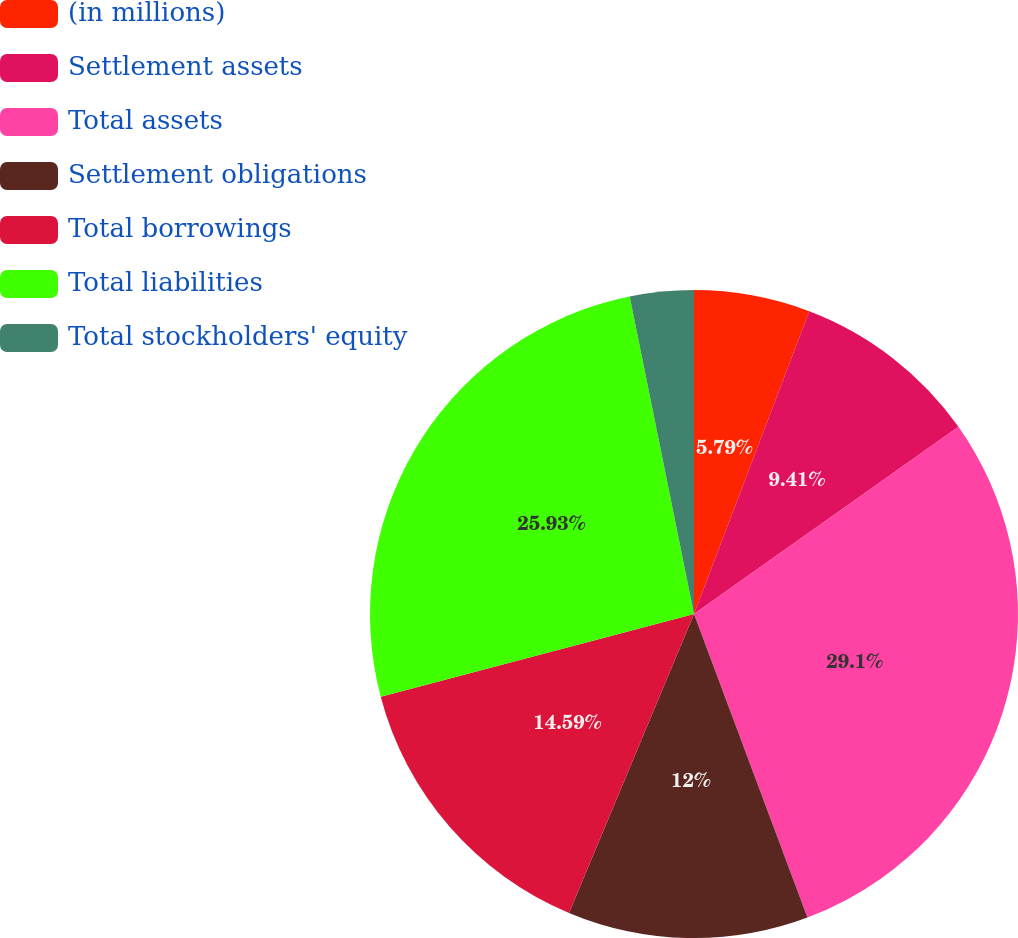Convert chart to OTSL. <chart><loc_0><loc_0><loc_500><loc_500><pie_chart><fcel>(in millions)<fcel>Settlement assets<fcel>Total assets<fcel>Settlement obligations<fcel>Total borrowings<fcel>Total liabilities<fcel>Total stockholders' equity<nl><fcel>5.79%<fcel>9.41%<fcel>29.11%<fcel>12.0%<fcel>14.59%<fcel>25.93%<fcel>3.18%<nl></chart> 